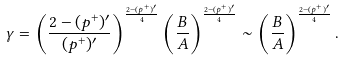<formula> <loc_0><loc_0><loc_500><loc_500>\gamma & = \left ( \frac { 2 - ( p ^ { + } ) ^ { \prime } } { ( p ^ { + } ) ^ { \prime } } \right ) ^ { \frac { 2 - ( p ^ { + } ) ^ { \prime } } { 4 } } \left ( \frac { B } { A } \right ) ^ { \frac { 2 - ( p ^ { + } ) ^ { \prime } } { 4 } } \sim \left ( \frac { B } { A } \right ) ^ { \frac { 2 - ( p ^ { + } ) ^ { \prime } } { 4 } } .</formula> 